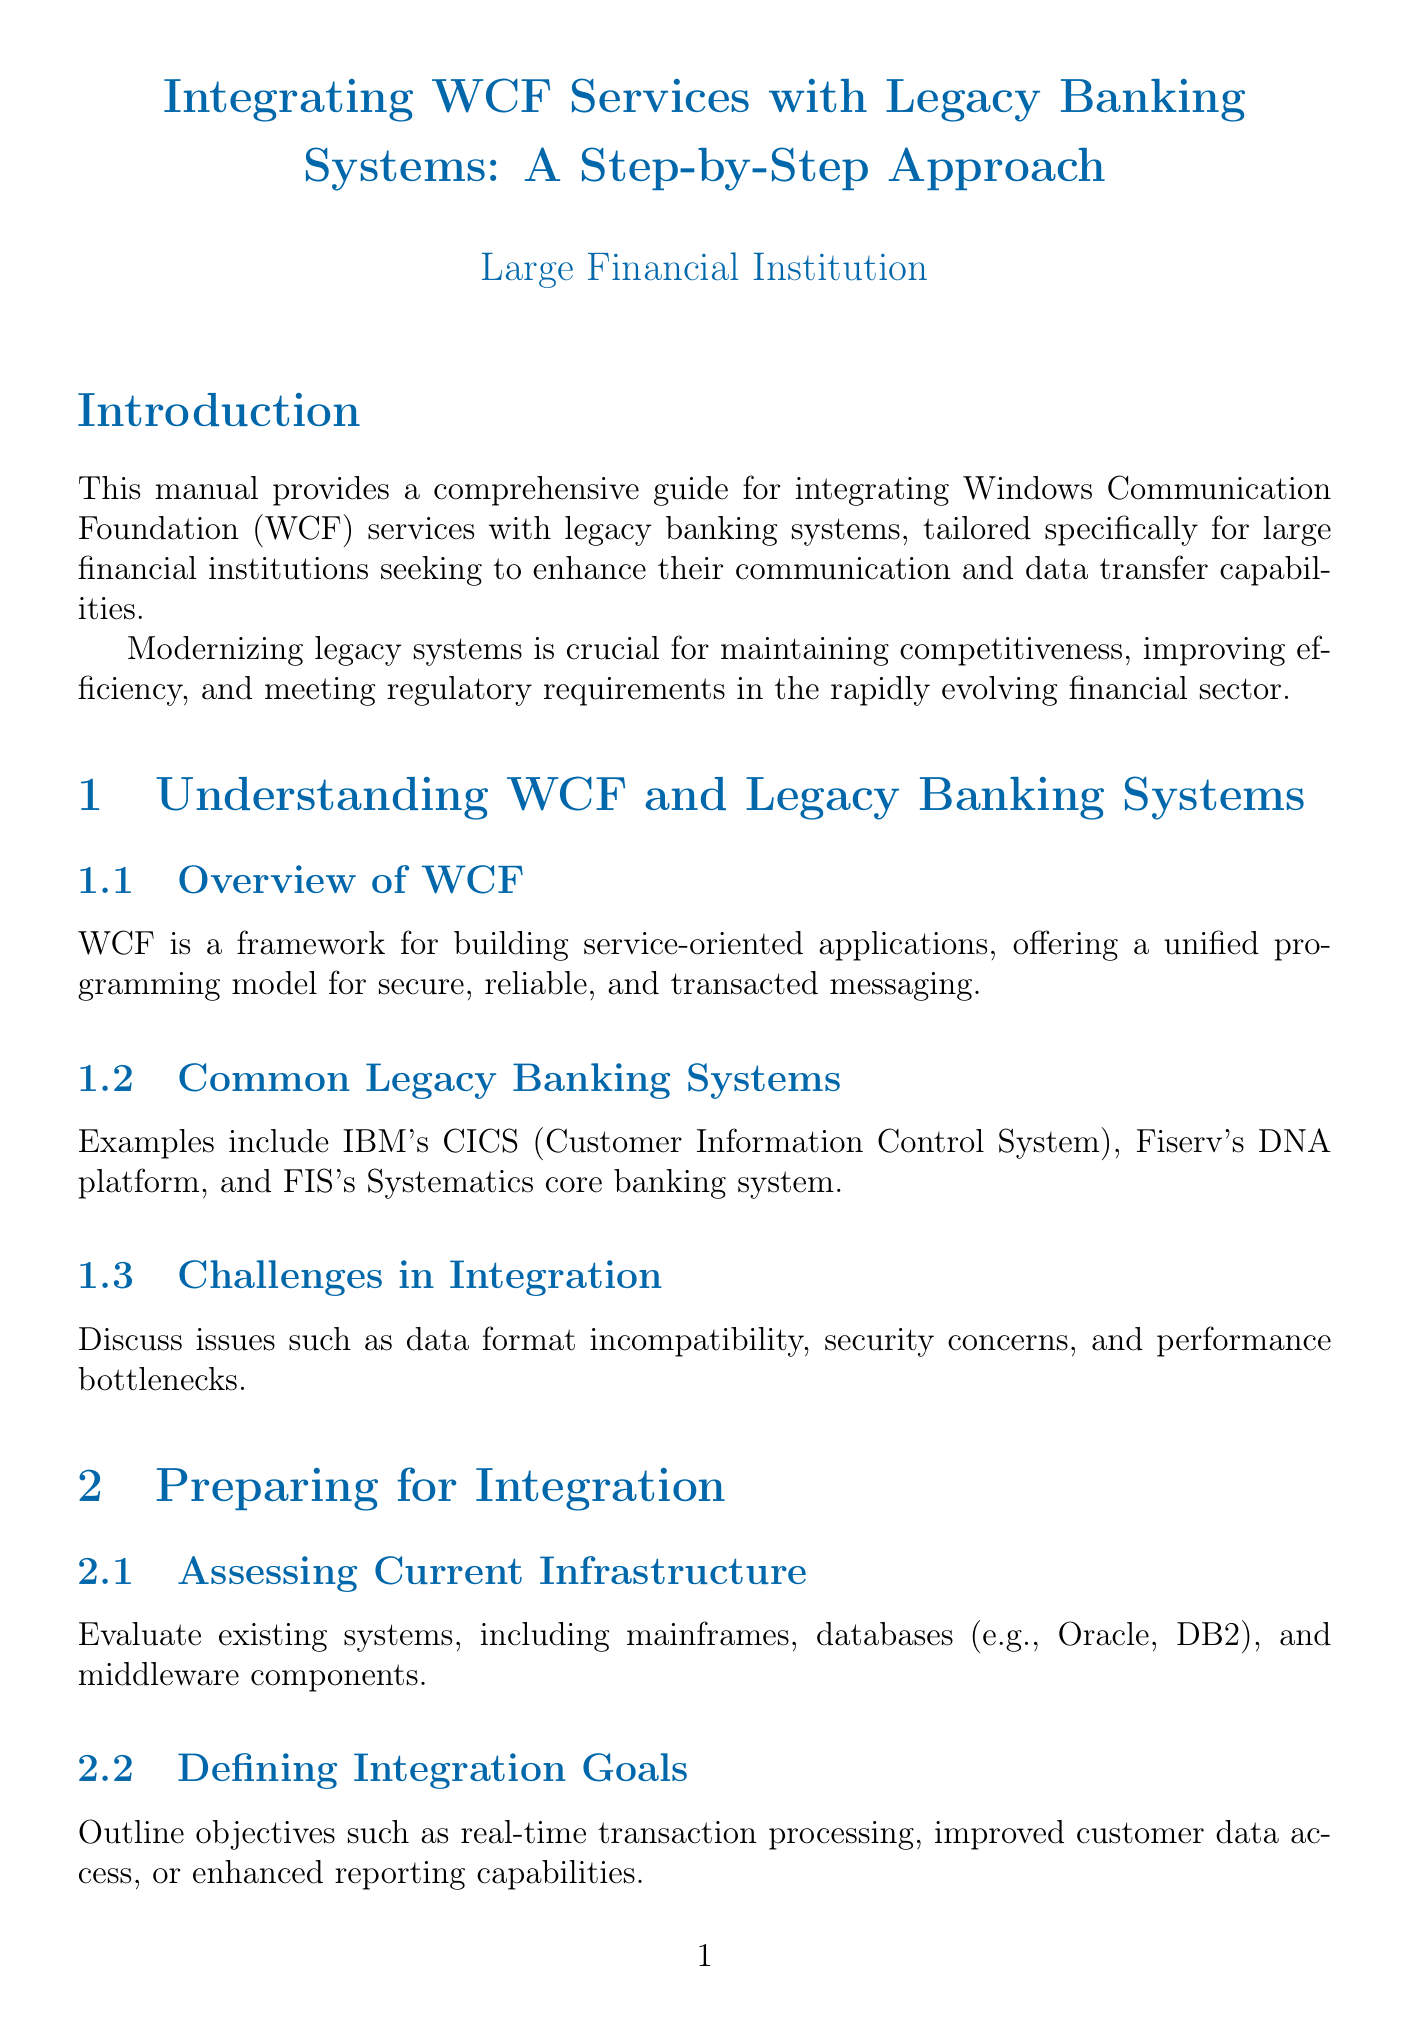What is the title of the manual? The title is clearly stated at the beginning of the document.
Answer: Integrating WCF Services with Legacy Banking Systems: A Step-by-Step Approach What framework does WCF utilize? This information is found in the "Overview of WCF" section, which describes WCF's characteristics.
Answer: Service-oriented applications What are two examples of common legacy banking systems? This information is provided in the section discussing legacy banking systems.
Answer: IBM's CICS, Fiserv's DNA platform Which testing frameworks are mentioned for unit testing? The specific testing frameworks are listed in the "Unit Testing WCF Services" section.
Answer: NUnit, MSTest What is a primary goal of defining integration goals? The document outlines the objectives of integration goals in the appropriate section.
Answer: Improved customer data access What technology is suggested for asynchronous communication? The document mentions technologies for asynchronous communication within the appropriate section.
Answer: IBM MQ What does the manual emphasize as crucial for modernization? This is stated in the introduction and highlights the importance of modernization.
Answer: Maintaining competitiveness Which compliance regulations are referenced in the document? Regulatory compliance requirements are addressed in the "Best Practices and Future Considerations" section.
Answer: SOX, Basel III What type of architecture is explored for future evolution of WCF services? This information is found in the section discussing future considerations for WCF services.
Answer: Microservices architecture 